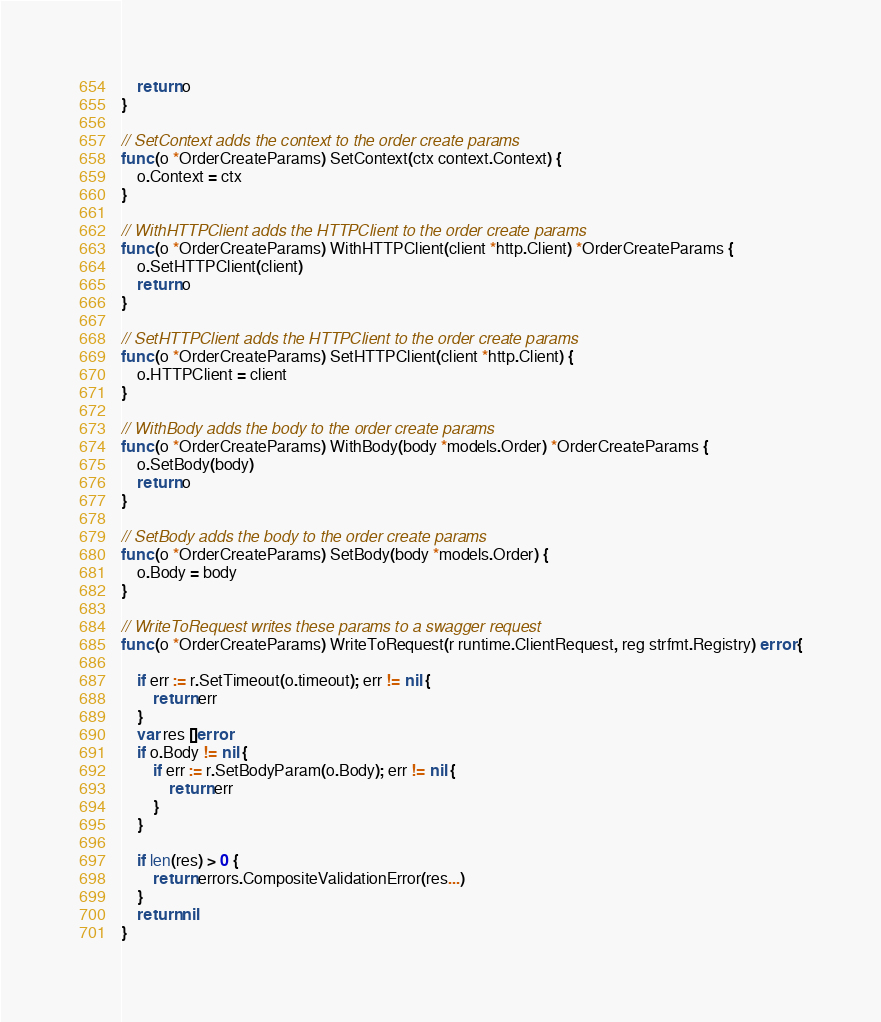<code> <loc_0><loc_0><loc_500><loc_500><_Go_>	return o
}

// SetContext adds the context to the order create params
func (o *OrderCreateParams) SetContext(ctx context.Context) {
	o.Context = ctx
}

// WithHTTPClient adds the HTTPClient to the order create params
func (o *OrderCreateParams) WithHTTPClient(client *http.Client) *OrderCreateParams {
	o.SetHTTPClient(client)
	return o
}

// SetHTTPClient adds the HTTPClient to the order create params
func (o *OrderCreateParams) SetHTTPClient(client *http.Client) {
	o.HTTPClient = client
}

// WithBody adds the body to the order create params
func (o *OrderCreateParams) WithBody(body *models.Order) *OrderCreateParams {
	o.SetBody(body)
	return o
}

// SetBody adds the body to the order create params
func (o *OrderCreateParams) SetBody(body *models.Order) {
	o.Body = body
}

// WriteToRequest writes these params to a swagger request
func (o *OrderCreateParams) WriteToRequest(r runtime.ClientRequest, reg strfmt.Registry) error {

	if err := r.SetTimeout(o.timeout); err != nil {
		return err
	}
	var res []error
	if o.Body != nil {
		if err := r.SetBodyParam(o.Body); err != nil {
			return err
		}
	}

	if len(res) > 0 {
		return errors.CompositeValidationError(res...)
	}
	return nil
}
</code> 